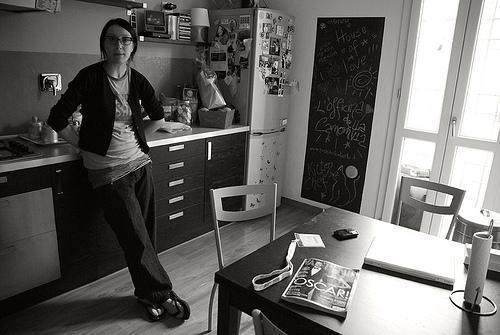How many people are in the picture?
Give a very brief answer. 1. 